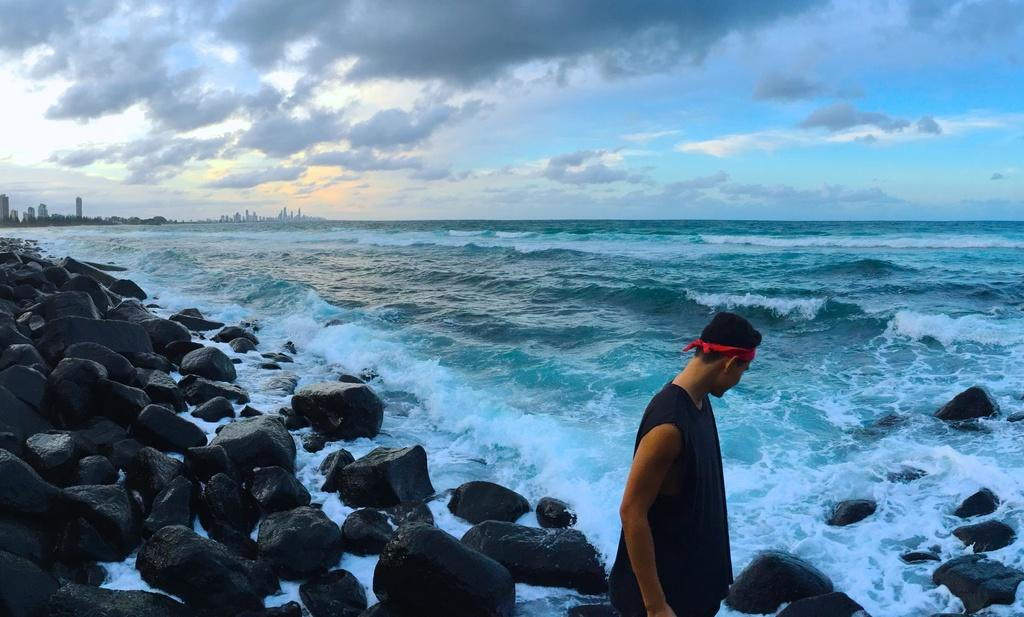What is the person in the image wearing? The person is wearing a black dress. What can be seen in the background of the image? There is water, rocks, buildings, and a blue and white sky visible in the image. What is the color of the sky in the image? The sky is blue and white in color. What type of balls can be seen hanging from the thread in the image? There is no thread or balls present in the image. Is there a shop visible in the image? There is no shop present in the image. 